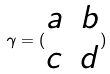Convert formula to latex. <formula><loc_0><loc_0><loc_500><loc_500>\gamma = ( \begin{matrix} a & b \\ c & d \end{matrix} )</formula> 